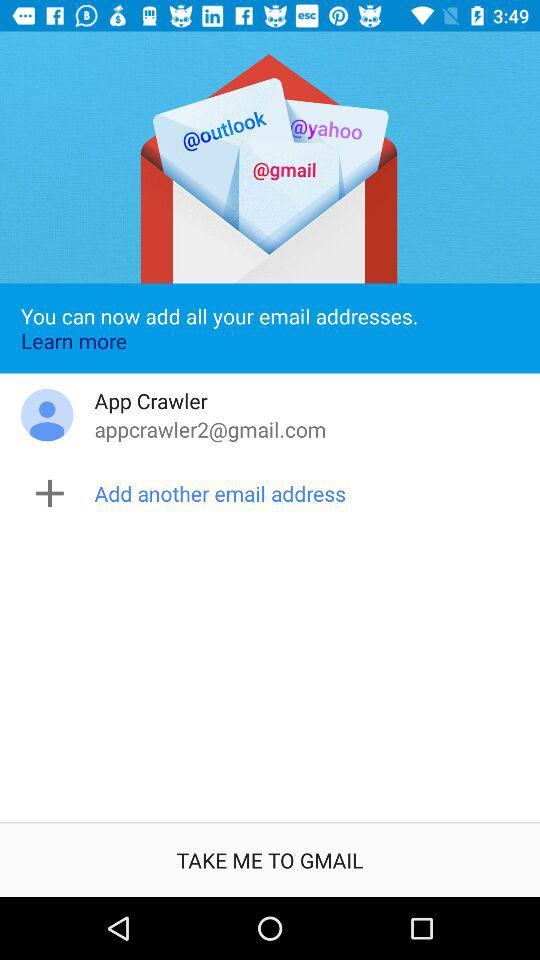What is the Gmail account address? The Gmail account address is appcrawler2@gmail.com. 